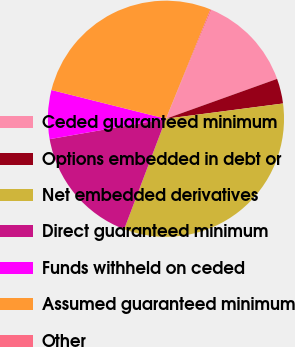<chart> <loc_0><loc_0><loc_500><loc_500><pie_chart><fcel>Ceded guaranteed minimum<fcel>Options embedded in debt or<fcel>Net embedded derivatives<fcel>Direct guaranteed minimum<fcel>Funds withheld on ceded<fcel>Assumed guaranteed minimum<fcel>Other<nl><fcel>13.22%<fcel>3.42%<fcel>32.82%<fcel>16.48%<fcel>6.68%<fcel>27.24%<fcel>0.15%<nl></chart> 